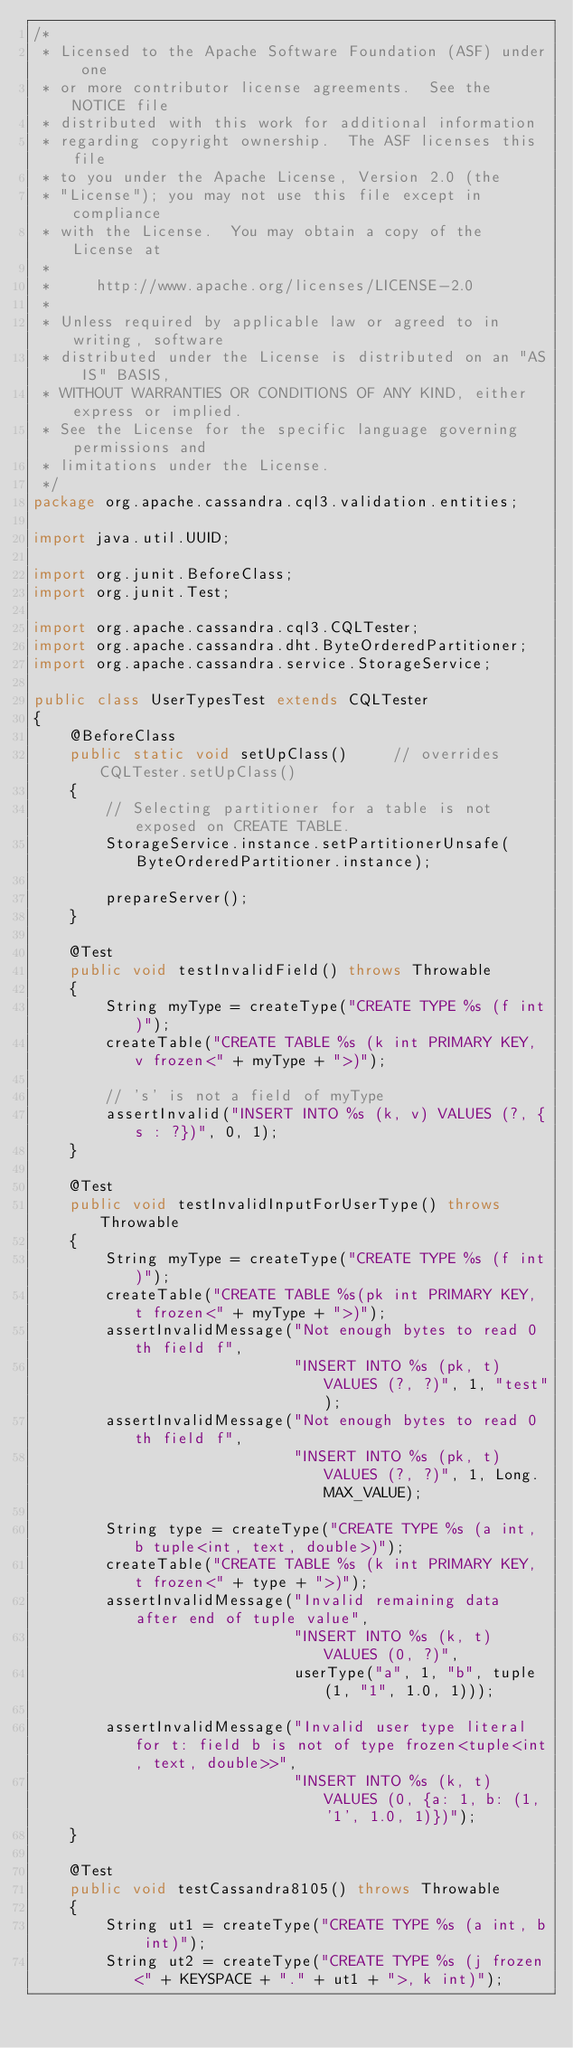Convert code to text. <code><loc_0><loc_0><loc_500><loc_500><_Java_>/*
 * Licensed to the Apache Software Foundation (ASF) under one
 * or more contributor license agreements.  See the NOTICE file
 * distributed with this work for additional information
 * regarding copyright ownership.  The ASF licenses this file
 * to you under the Apache License, Version 2.0 (the
 * "License"); you may not use this file except in compliance
 * with the License.  You may obtain a copy of the License at
 *
 *     http://www.apache.org/licenses/LICENSE-2.0
 *
 * Unless required by applicable law or agreed to in writing, software
 * distributed under the License is distributed on an "AS IS" BASIS,
 * WITHOUT WARRANTIES OR CONDITIONS OF ANY KIND, either express or implied.
 * See the License for the specific language governing permissions and
 * limitations under the License.
 */
package org.apache.cassandra.cql3.validation.entities;

import java.util.UUID;

import org.junit.BeforeClass;
import org.junit.Test;

import org.apache.cassandra.cql3.CQLTester;
import org.apache.cassandra.dht.ByteOrderedPartitioner;
import org.apache.cassandra.service.StorageService;

public class UserTypesTest extends CQLTester
{
    @BeforeClass
    public static void setUpClass()     // overrides CQLTester.setUpClass()
    {
        // Selecting partitioner for a table is not exposed on CREATE TABLE.
        StorageService.instance.setPartitionerUnsafe(ByteOrderedPartitioner.instance);

        prepareServer();
    }

    @Test
    public void testInvalidField() throws Throwable
    {
        String myType = createType("CREATE TYPE %s (f int)");
        createTable("CREATE TABLE %s (k int PRIMARY KEY, v frozen<" + myType + ">)");

        // 's' is not a field of myType
        assertInvalid("INSERT INTO %s (k, v) VALUES (?, {s : ?})", 0, 1);
    }

    @Test
    public void testInvalidInputForUserType() throws Throwable
    {
        String myType = createType("CREATE TYPE %s (f int)");
        createTable("CREATE TABLE %s(pk int PRIMARY KEY, t frozen<" + myType + ">)");
        assertInvalidMessage("Not enough bytes to read 0th field f",
                             "INSERT INTO %s (pk, t) VALUES (?, ?)", 1, "test");
        assertInvalidMessage("Not enough bytes to read 0th field f",
                             "INSERT INTO %s (pk, t) VALUES (?, ?)", 1, Long.MAX_VALUE);

        String type = createType("CREATE TYPE %s (a int, b tuple<int, text, double>)");
        createTable("CREATE TABLE %s (k int PRIMARY KEY, t frozen<" + type + ">)");
        assertInvalidMessage("Invalid remaining data after end of tuple value",
                             "INSERT INTO %s (k, t) VALUES (0, ?)",
                             userType("a", 1, "b", tuple(1, "1", 1.0, 1)));

        assertInvalidMessage("Invalid user type literal for t: field b is not of type frozen<tuple<int, text, double>>",
                             "INSERT INTO %s (k, t) VALUES (0, {a: 1, b: (1, '1', 1.0, 1)})");
    }

    @Test
    public void testCassandra8105() throws Throwable
    {
        String ut1 = createType("CREATE TYPE %s (a int, b int)");
        String ut2 = createType("CREATE TYPE %s (j frozen<" + KEYSPACE + "." + ut1 + ">, k int)");</code> 